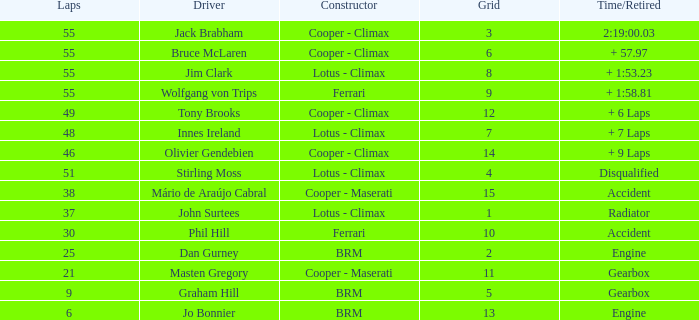Tell me the laps for 3 grids 55.0. 